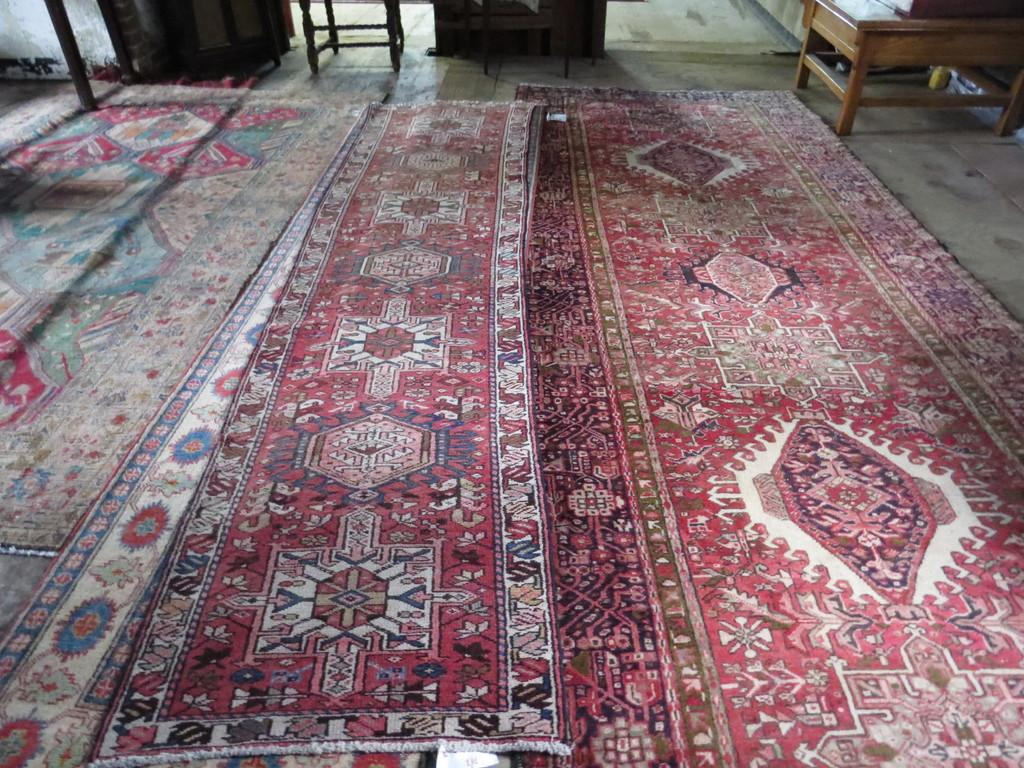What type of floor covering is visible in the image? There is a carpet on the floor in the image. What type of furniture can be seen in the image? There are tables in the image. What type of bell is hanging from the ceiling in the image? There is no bell present in the image; it only features a carpet on the floor and tables. What story is being told by the objects in the image? The objects in the image do not tell a story; they are simply a carpet and tables. 